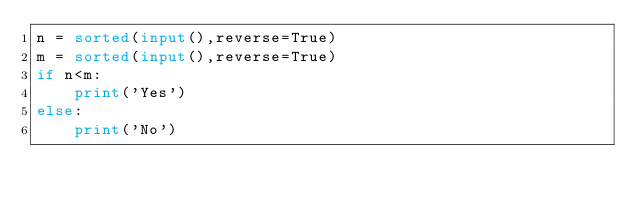Convert code to text. <code><loc_0><loc_0><loc_500><loc_500><_Python_>n = sorted(input(),reverse=True)
m = sorted(input(),reverse=True)
if n<m:
    print('Yes')
else:
    print('No')</code> 